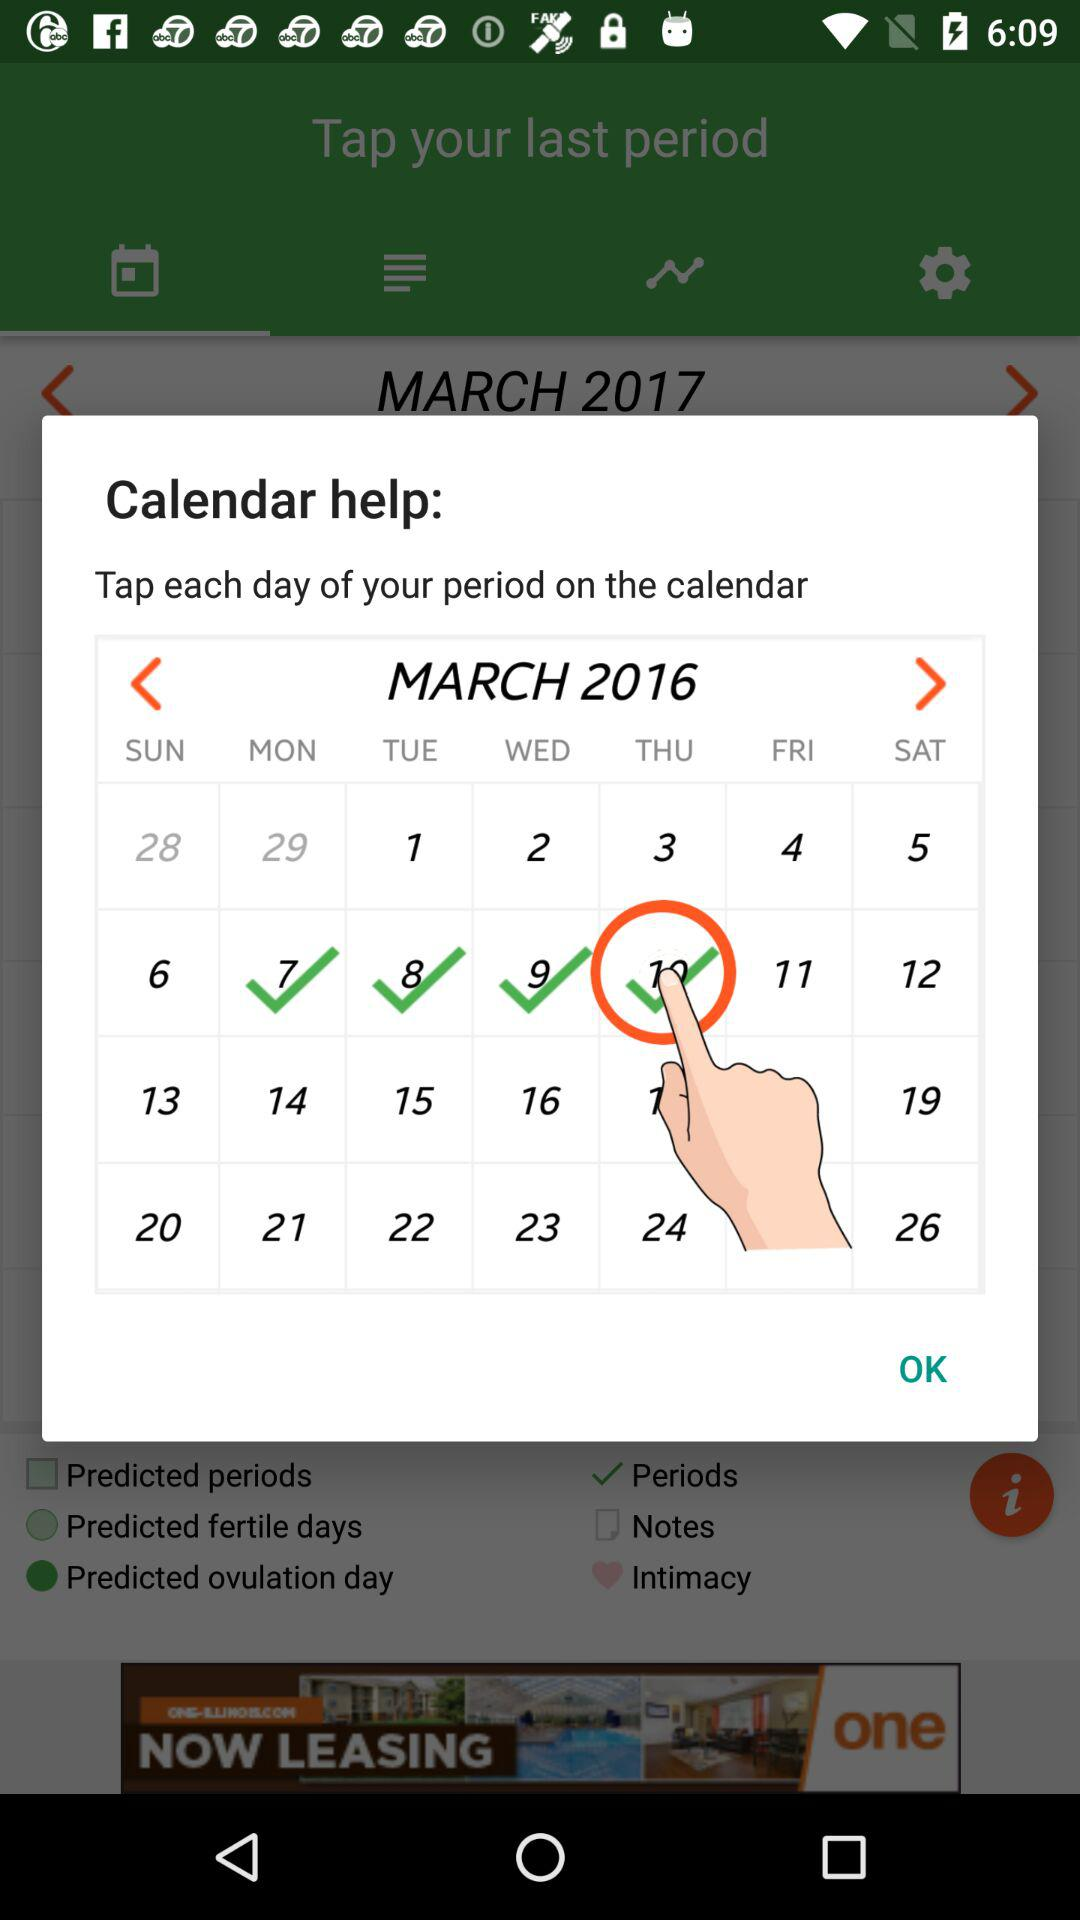Which day falls on 10 March 2016? The day is Thursday. 